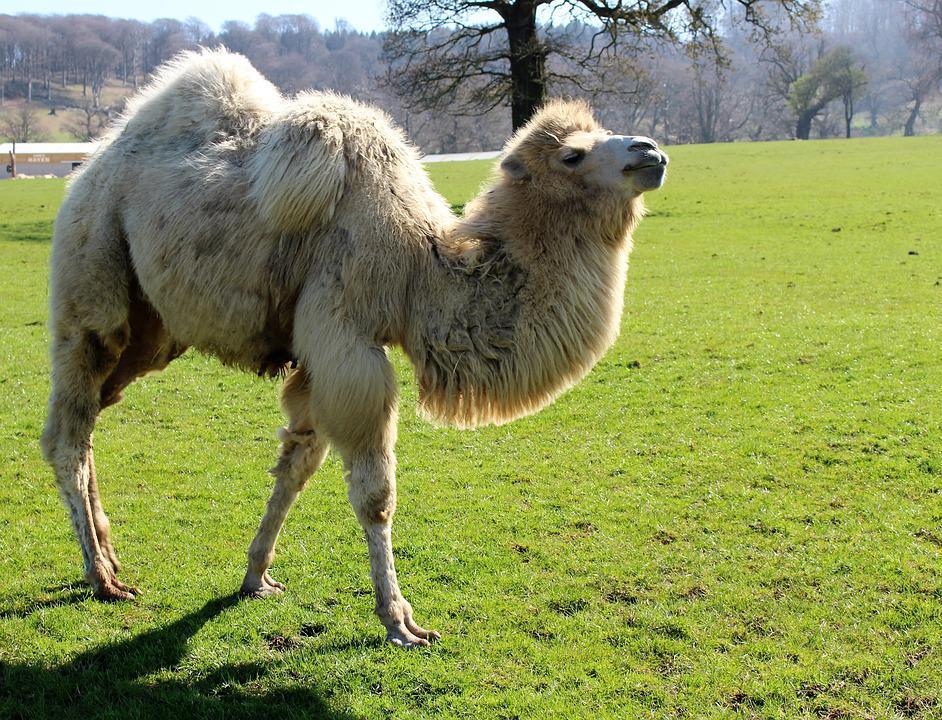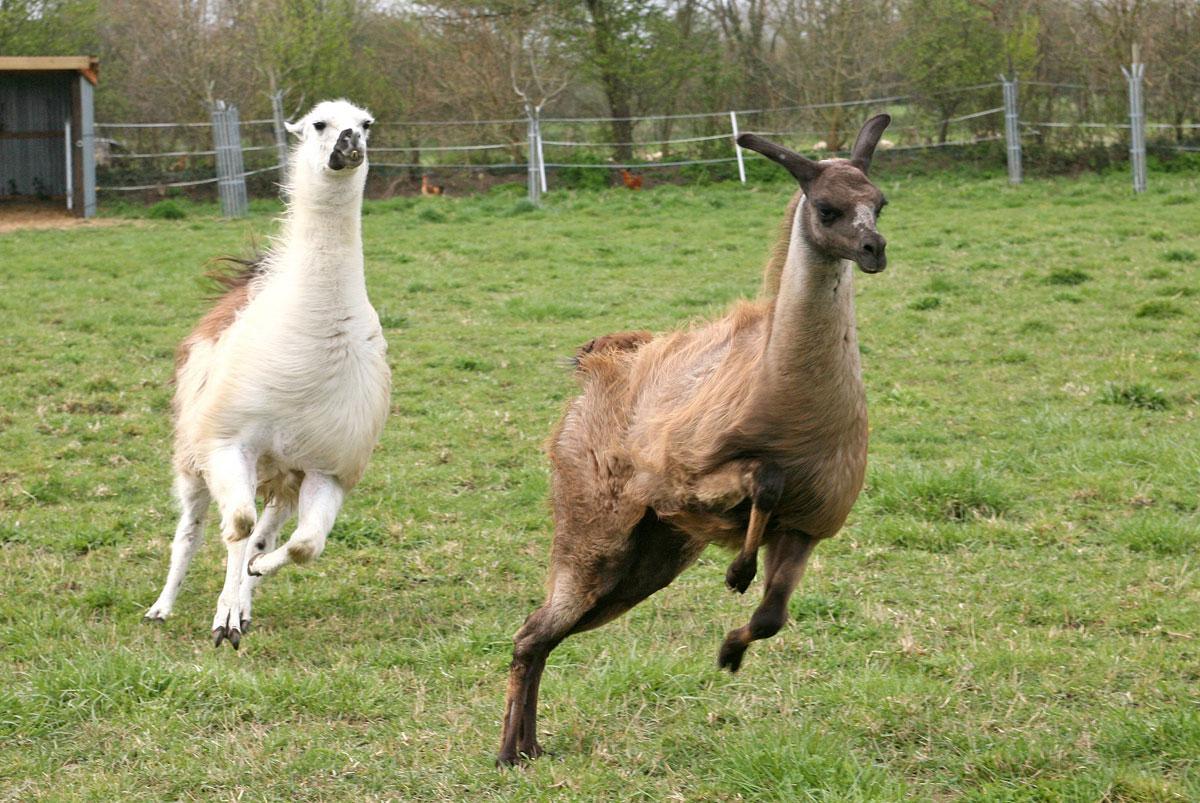The first image is the image on the left, the second image is the image on the right. For the images shown, is this caption "There is exactly one llama in the left image." true? Answer yes or no. Yes. 